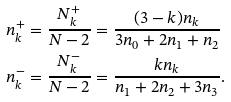<formula> <loc_0><loc_0><loc_500><loc_500>& n _ { k } ^ { + } = \frac { N _ { k } ^ { + } } { N - 2 } = \frac { ( 3 - k ) n _ { k } } { 3 n _ { 0 } + 2 n _ { 1 } + n _ { 2 } } \\ & n _ { k } ^ { - } = \frac { N _ { k } ^ { - } } { N - 2 } = \frac { k n _ { k } } { n _ { 1 } + 2 n _ { 2 } + 3 n _ { 3 } } .</formula> 